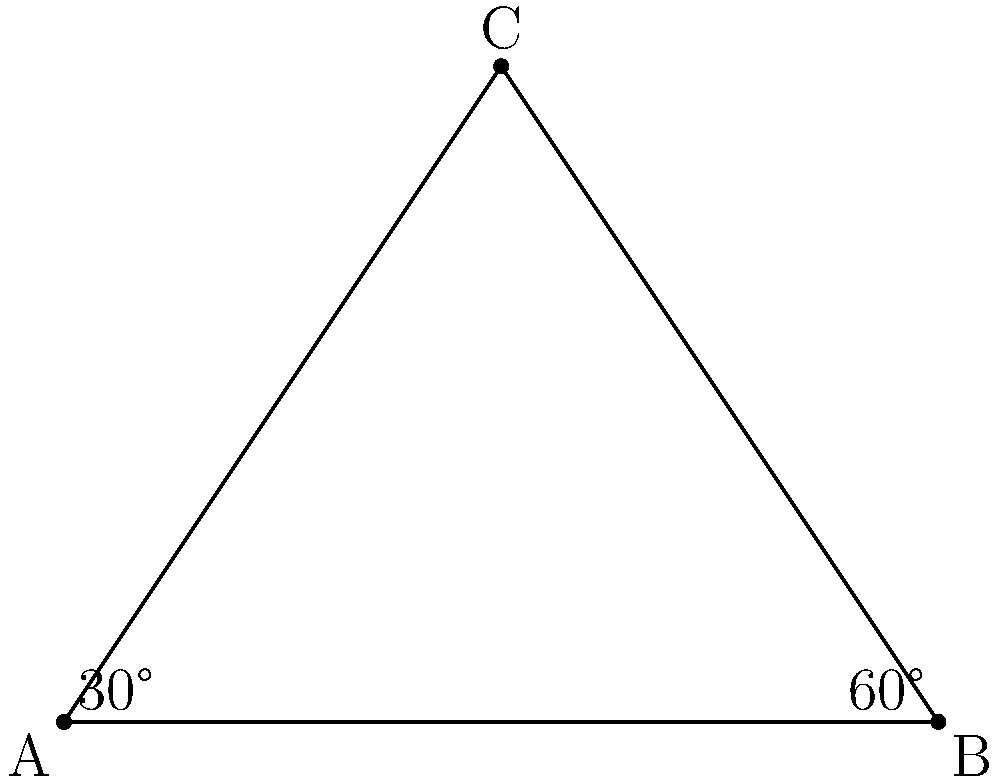At the pet store, you notice a beautiful tropical fish with unique fin extensions. When fully extended, its fins form a triangle ABC as shown in the diagram. If the angle at point A is 30° and the angle at point B is 60°, what is the measure of angle C? Let's approach this step-by-step:

1) In any triangle, the sum of all interior angles is always 180°. This is a fundamental property of triangles.

2) We are given two angles in the triangle:
   - Angle A = 30°
   - Angle B = 60°

3) Let's call the angle at C that we're looking for x°.

4) We can set up an equation based on the fact that all angles in a triangle sum to 180°:
   
   $30° + 60° + x° = 180°$

5) Simplify the left side of the equation:
   
   $90° + x° = 180°$

6) Subtract 90° from both sides:
   
   $x° = 180° - 90° = 90°$

Therefore, the measure of angle C is 90°.
Answer: 90° 